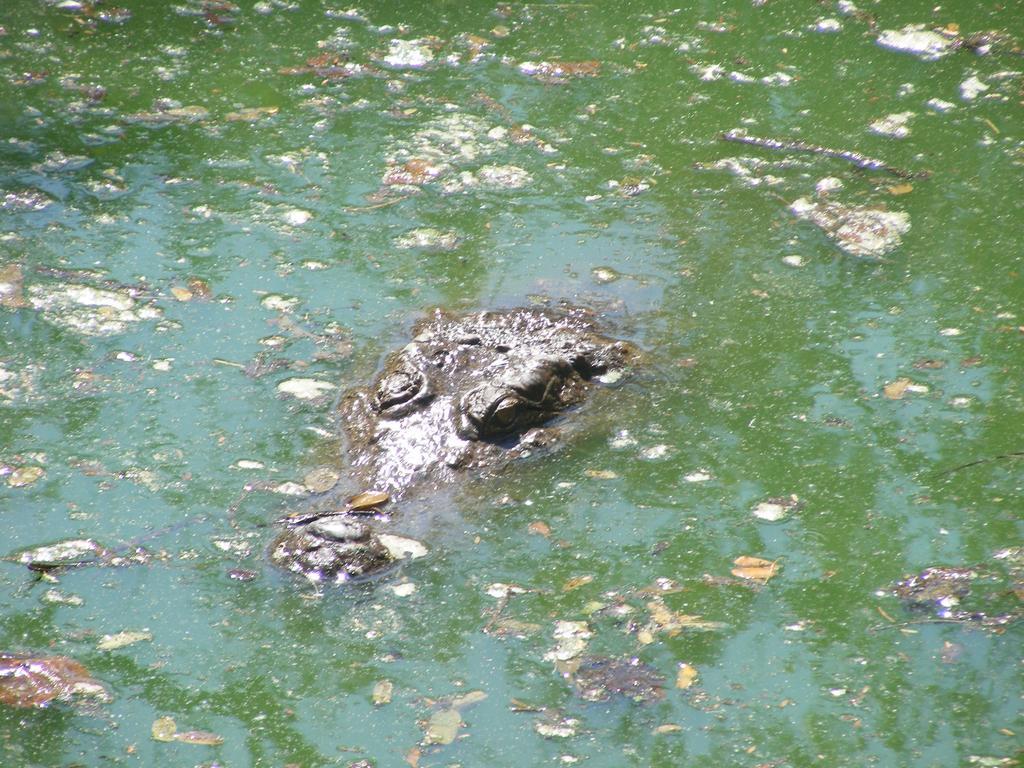Please provide a concise description of this image. In this image we can see a crocodile which is in water and water is in green color. 